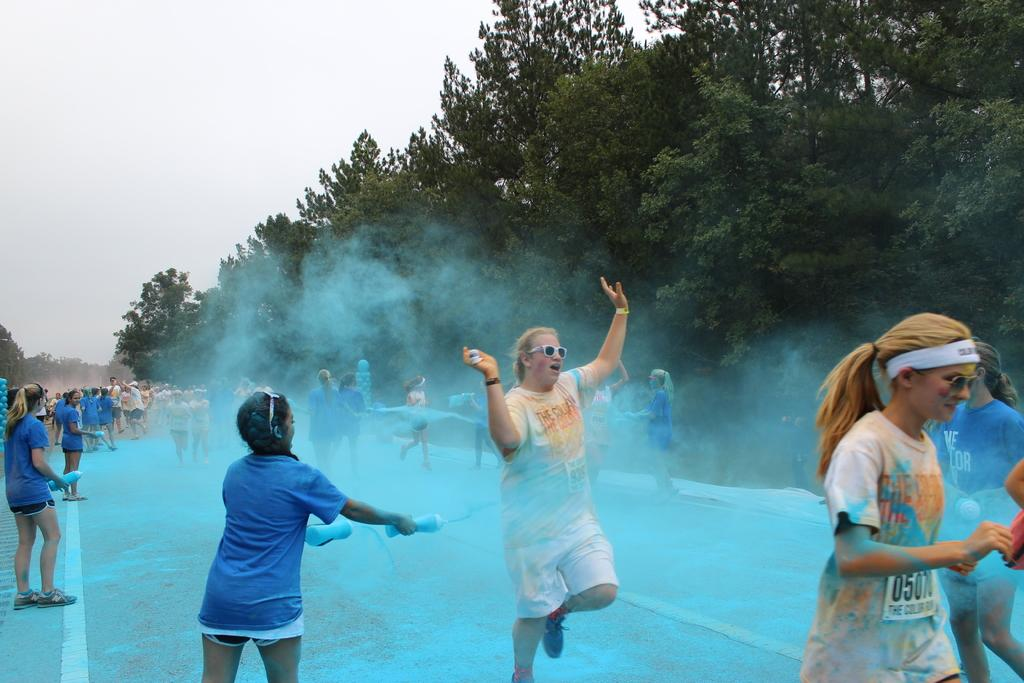What are the people in the image doing? The people in the image are standing on the floor and sprinkling blue color powder on themselves. Where are the people located in the image? The people are standing on the floor. What can be seen in the background of the image? There is sky and trees visible in the background of the image. What type of lamp is hanging from the carriage in the image? There is no lamp or carriage present in the image; it features people standing on the floor and sprinkling blue color powder on themselves. What statement is being made by the people in the image? There is no statement being made by the people in the image; they are simply sprinkling blue color powder on themselves. 